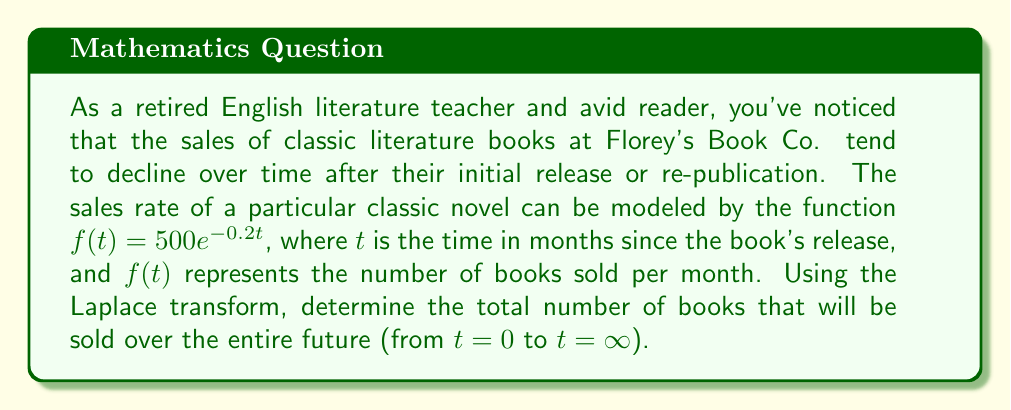Give your solution to this math problem. To solve this problem, we'll use the Laplace transform and its properties. Let's break it down step-by-step:

1) The Laplace transform of $f(t)$ is defined as:

   $$F(s) = \mathcal{L}\{f(t)\} = \int_0^\infty f(t)e^{-st}dt$$

2) In our case, $f(t) = 500e^{-0.2t}$, so we need to calculate:

   $$F(s) = \int_0^\infty 500e^{-0.2t}e^{-st}dt = 500\int_0^\infty e^{-(s+0.2)t}dt$$

3) This integral can be solved as follows:

   $$F(s) = 500 \left[-\frac{1}{s+0.2}e^{-(s+0.2)t}\right]_0^\infty = 500 \left(0 - \left(-\frac{1}{s+0.2}\right)\right) = \frac{500}{s+0.2}$$

4) Now, we can use the Final Value Theorem of Laplace transforms. This theorem states that for a function $f(t)$ with Laplace transform $F(s)$, if the limit exists:

   $$\lim_{t \to \infty} f(t) = \lim_{s \to 0} sF(s)$$

5) In our case, we're interested in the total number of books sold, which is the integral of $f(t)$ from 0 to infinity. This is equivalent to:

   $$\lim_{s \to 0} F(s) = \lim_{s \to 0} \frac{500}{s+0.2} = \frac{500}{0.2} = 2500$$

Therefore, the total number of books that will be sold over all time is 2500.
Answer: 2500 books 